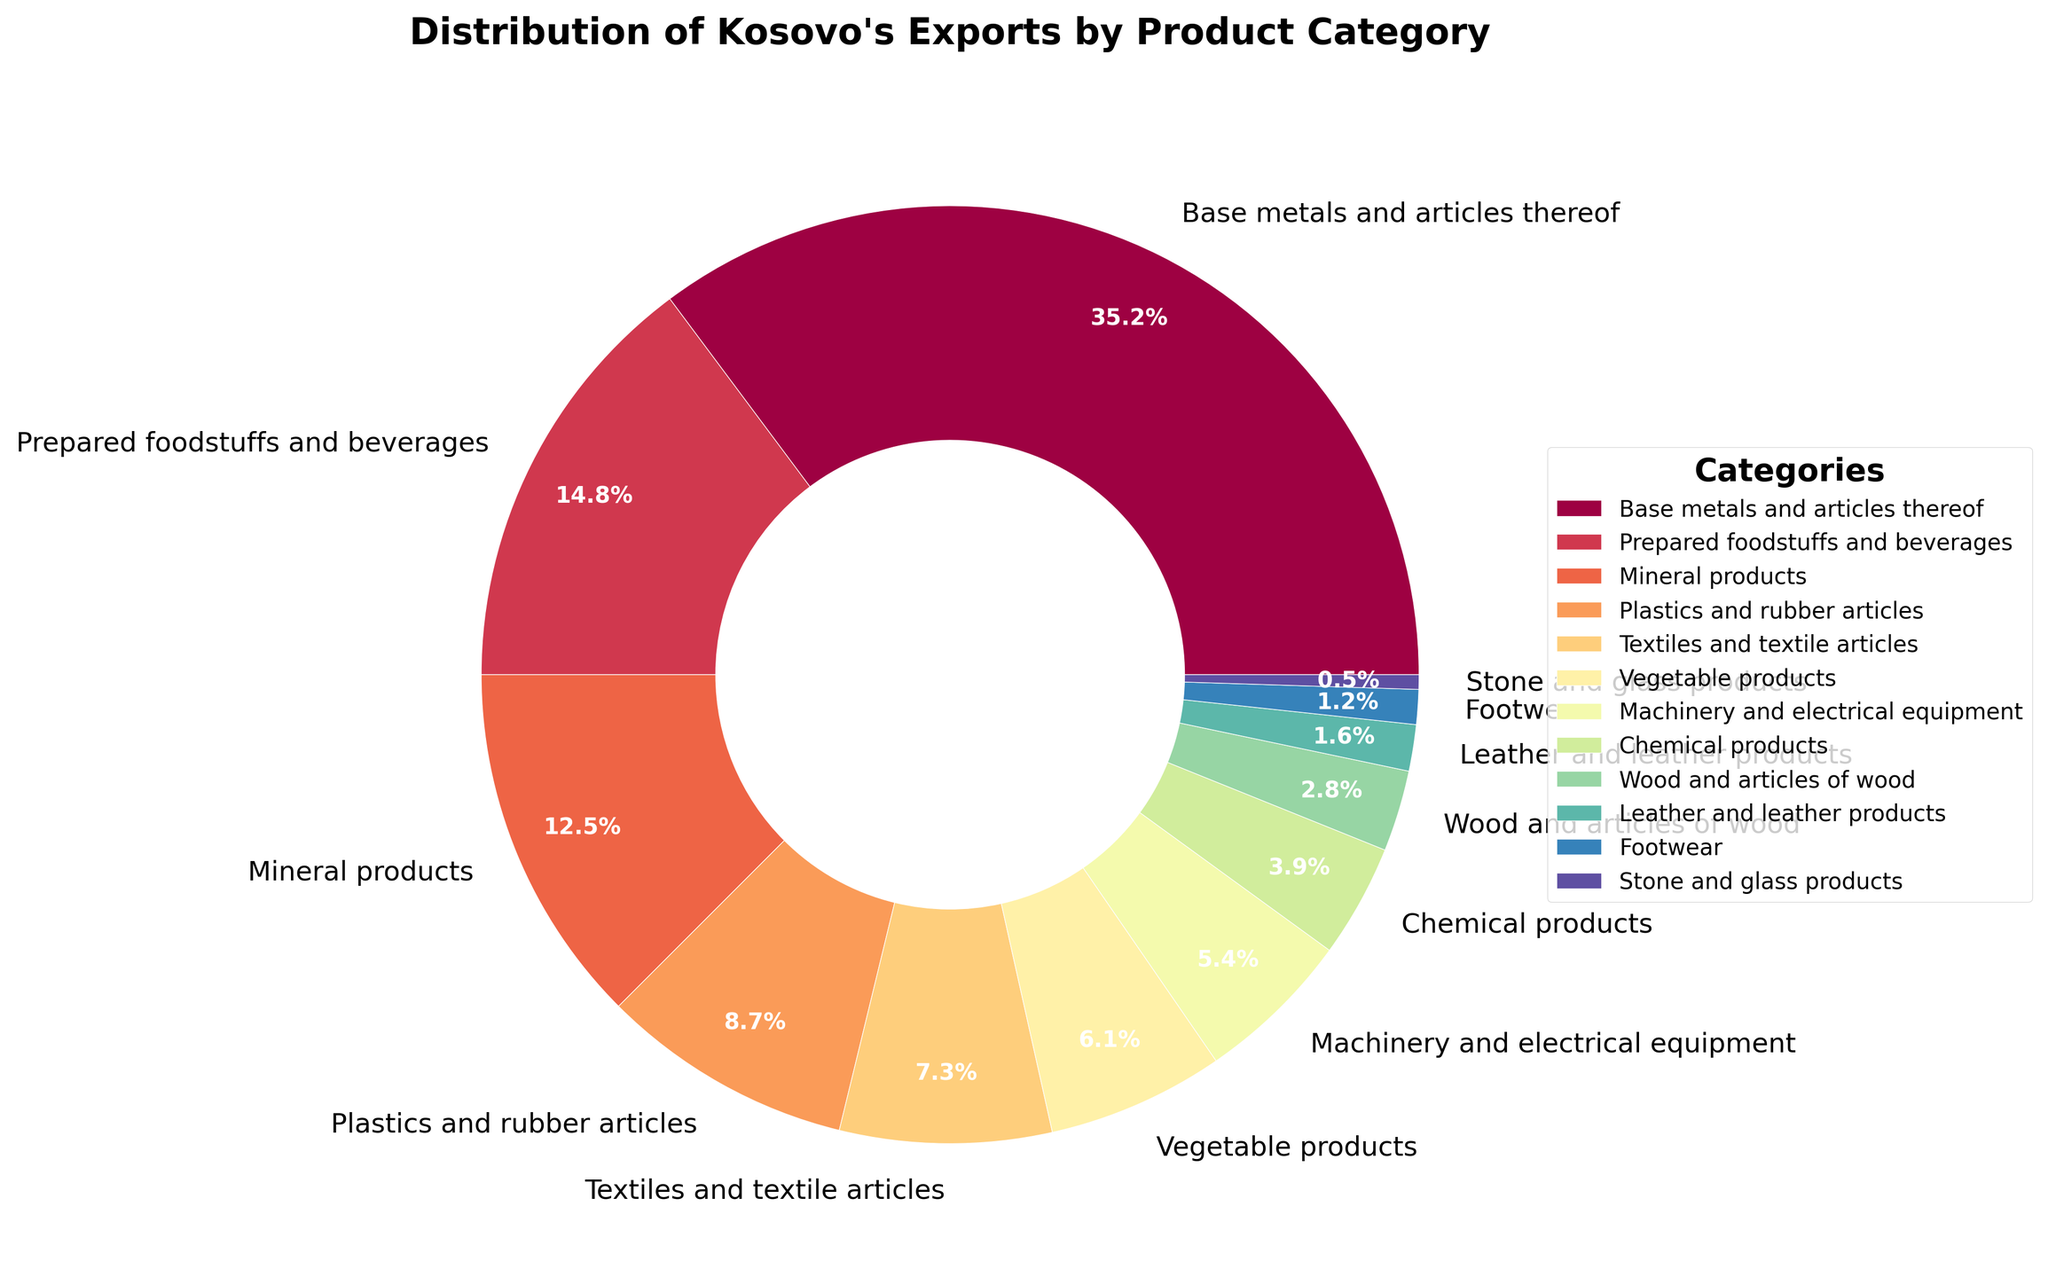What is the largest product category of Kosovo's exports? To determine the largest product category, look at the slice of the pie chart with the largest percentage. The chart shows that Base metals and articles thereof have the largest slice at 35.2%.
Answer: Base metals and articles thereof Which two categories combined make up the highest percentage of exports? First, identify the top two percentages. The largest is Base metals and articles thereof (35.2%), and the second largest is Prepared foodstuffs and beverages (14.8%). Add these two percentages: 35.2 + 14.8 = 50%.
Answer: Base metals and articles thereof and Prepared foodstuffs and beverages What are the combined percentages of the three smallest categories of exports? Identify the three smallest percentages: Stone and glass products (0.5%), Footwear (1.2%), and Leather and leather products (1.6%). Add these percentages: 0.5 + 1.2 + 1.6 = 3.3%.
Answer: 3.3% Which category, between Vegetable products and Machinery and electrical equipment, has a higher export percentage? Compare the percentages for Vegetable products (6.1%) and Machinery and electrical equipment (5.4%). Since 6.1% is greater than 5.4%, Vegetable products have a higher export percentage.
Answer: Vegetable products Is the percentage of Prepared foodstuffs and beverages greater than the sum of Wood and articles of wood and Chemical products? Compare Prepared foodstuffs and beverages (14.8%) with the combined percentages of Wood and articles of wood (2.8%) and Chemical products (3.9%): 2.8 + 3.9 = 6.7%. Since 14.8% is greater than 6.7%, Prepared foodstuffs and beverages have a greater percentage.
Answer: Yes What is the combined percentage of Mineral products and Plastics and rubber articles? Add the percentages of Mineral products (12.5%) and Plastics and rubber articles (8.7%): 12.5 + 8.7 = 21.2%.
Answer: 21.2% What is the percentage difference between Textiles and textile articles and Leather and leather products? Subtract the percentage of Leather and leather products (1.6%) from Textiles and textile articles (7.3%): 7.3 - 1.6 = 5.7%.
Answer: 5.7% Which categories have a percentage greater than 10%? Identify categories with percentages above 10%: Base metals and articles thereof (35.2%), Prepared foodstuffs and beverages (14.8%), and Mineral products (12.5%).
Answer: Base metals and articles thereof, Prepared foodstuffs and beverages, and Mineral products 